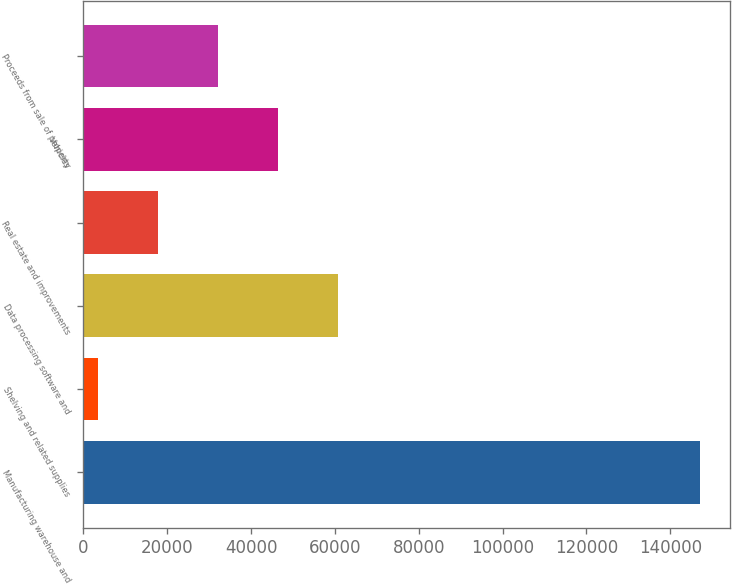Convert chart to OTSL. <chart><loc_0><loc_0><loc_500><loc_500><bar_chart><fcel>Manufacturing warehouse and<fcel>Shelving and related supplies<fcel>Data processing software and<fcel>Real estate and improvements<fcel>Vehicles<fcel>Proceeds from sale of property<nl><fcel>147000<fcel>3400<fcel>60840<fcel>17760<fcel>46480<fcel>32120<nl></chart> 